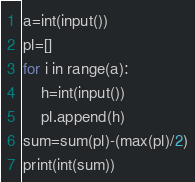Convert code to text. <code><loc_0><loc_0><loc_500><loc_500><_Python_>a=int(input())
pl=[]
for i in range(a):
	h=int(input())
	pl.append(h)
sum=sum(pl)-(max(pl)/2)
print(int(sum))</code> 